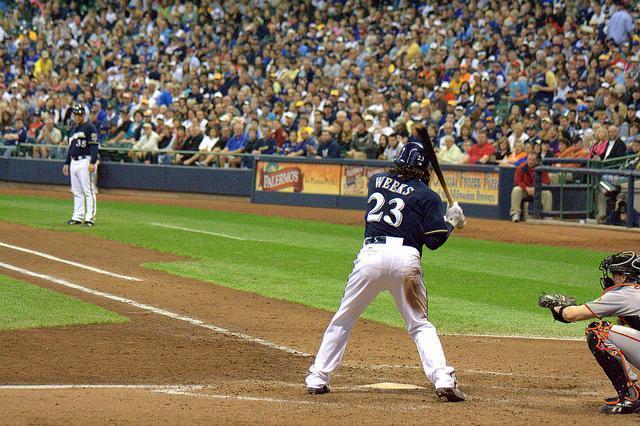How many people are there?
Give a very brief answer. 5. 